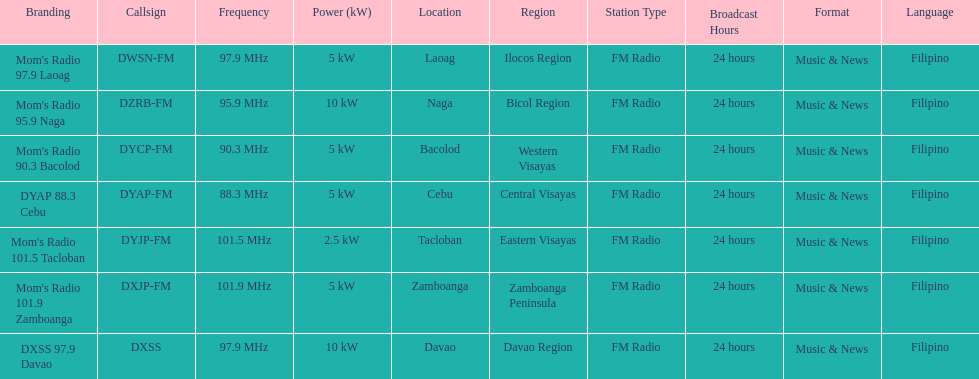What brandings have a power of 5 kw? Mom's Radio 97.9 Laoag, Mom's Radio 90.3 Bacolod, DYAP 88.3 Cebu, Mom's Radio 101.9 Zamboanga. Which of these has a call-sign beginning with dy? Mom's Radio 90.3 Bacolod, DYAP 88.3 Cebu. Which of those uses the lowest frequency? DYAP 88.3 Cebu. 